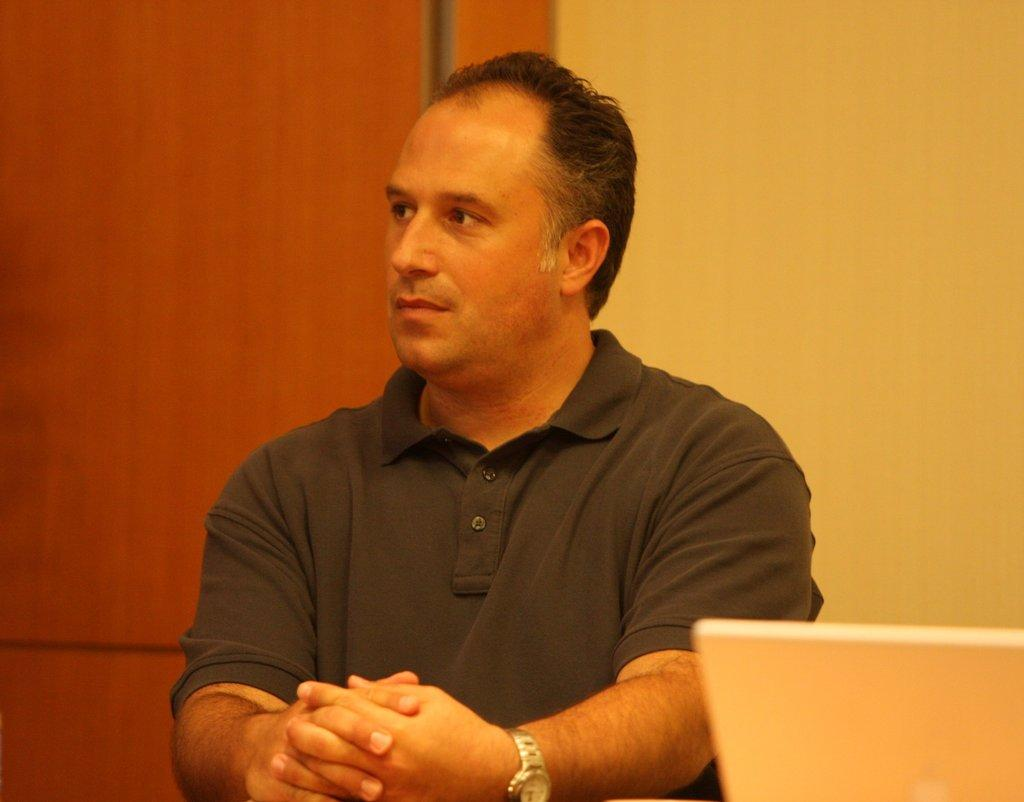Where was the image taken? The image is taken indoors. What can be seen in the background of the image? There is a wall in the background of the image. What electronic device is visible on the right side of the image? There is a laptop on the right side of the image. Who is the main subject in the image? There is a man in the middle of the image. What type of creature is involved in the battle depicted in the image? There is no battle or creature present in the image; it features a man and a laptop indoors. 